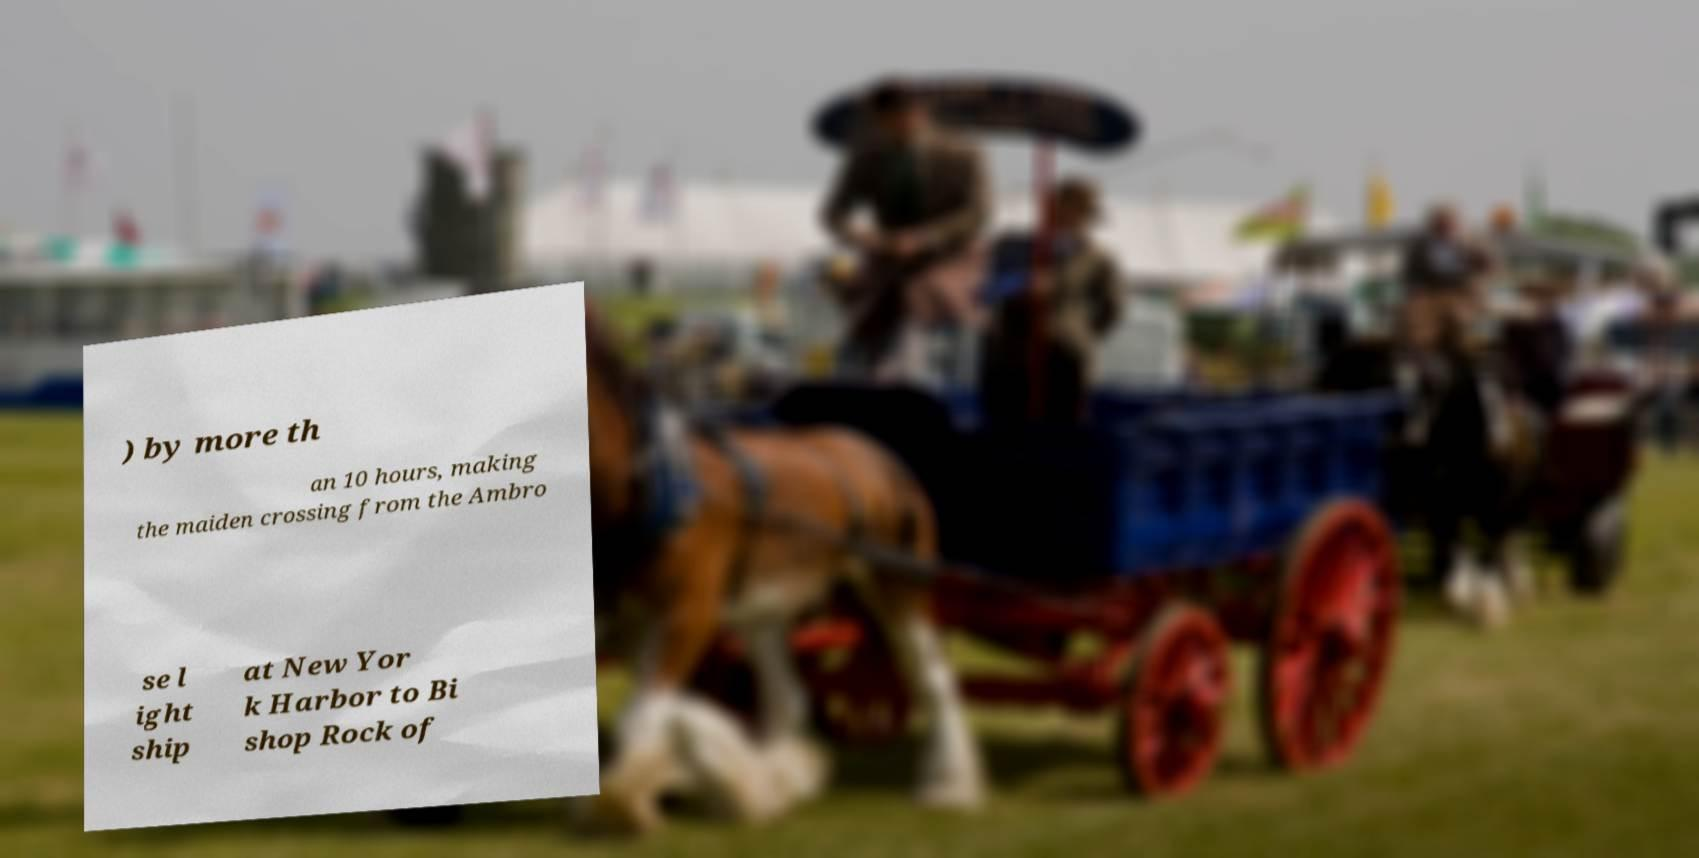Can you accurately transcribe the text from the provided image for me? ) by more th an 10 hours, making the maiden crossing from the Ambro se l ight ship at New Yor k Harbor to Bi shop Rock of 